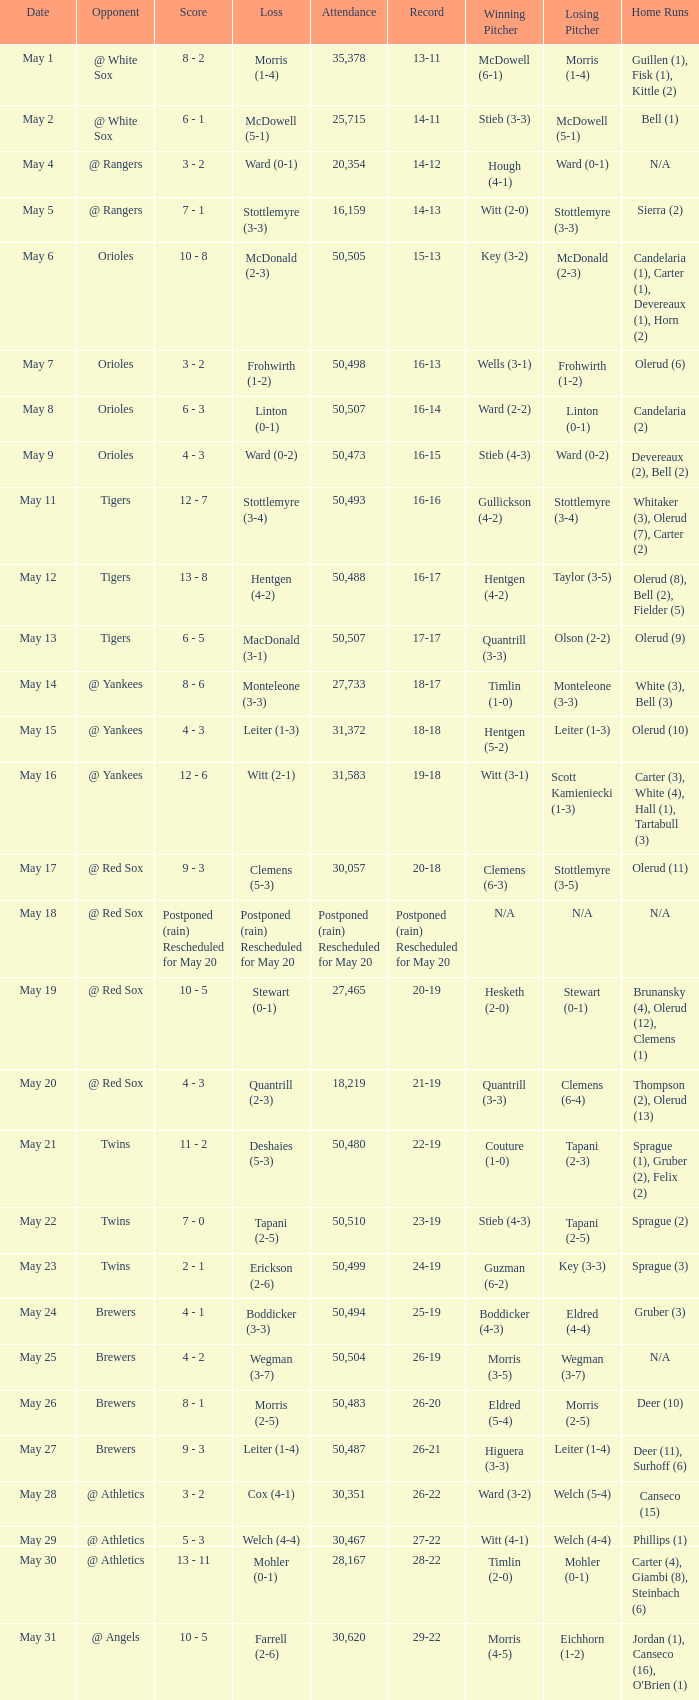Help me parse the entirety of this table. {'header': ['Date', 'Opponent', 'Score', 'Loss', 'Attendance', 'Record', 'Winning Pitcher', 'Losing Pitcher', 'Home Runs'], 'rows': [['May 1', '@ White Sox', '8 - 2', 'Morris (1-4)', '35,378', '13-11', 'McDowell (6-1)', 'Morris (1-4)', 'Guillen (1), Fisk (1), Kittle (2)'], ['May 2', '@ White Sox', '6 - 1', 'McDowell (5-1)', '25,715', '14-11', 'Stieb (3-3)', 'McDowell (5-1)', 'Bell (1)'], ['May 4', '@ Rangers', '3 - 2', 'Ward (0-1)', '20,354', '14-12', 'Hough (4-1)', 'Ward (0-1)', 'N/A'], ['May 5', '@ Rangers', '7 - 1', 'Stottlemyre (3-3)', '16,159', '14-13', 'Witt (2-0)', 'Stottlemyre (3-3)', 'Sierra (2)'], ['May 6', 'Orioles', '10 - 8', 'McDonald (2-3)', '50,505', '15-13', 'Key (3-2)', 'McDonald (2-3)', 'Candelaria (1), Carter (1), Devereaux (1), Horn (2)'], ['May 7', 'Orioles', '3 - 2', 'Frohwirth (1-2)', '50,498', '16-13', 'Wells (3-1)', 'Frohwirth (1-2)', 'Olerud (6)'], ['May 8', 'Orioles', '6 - 3', 'Linton (0-1)', '50,507', '16-14', 'Ward (2-2)', 'Linton (0-1)', 'Candelaria (2)'], ['May 9', 'Orioles', '4 - 3', 'Ward (0-2)', '50,473', '16-15', 'Stieb (4-3)', 'Ward (0-2)', 'Devereaux (2), Bell (2)'], ['May 11', 'Tigers', '12 - 7', 'Stottlemyre (3-4)', '50,493', '16-16', 'Gullickson (4-2)', 'Stottlemyre (3-4)', 'Whitaker (3), Olerud (7), Carter (2)'], ['May 12', 'Tigers', '13 - 8', 'Hentgen (4-2)', '50,488', '16-17', 'Hentgen (4-2)', 'Taylor (3-5)', 'Olerud (8), Bell (2), Fielder (5)'], ['May 13', 'Tigers', '6 - 5', 'MacDonald (3-1)', '50,507', '17-17', 'Quantrill (3-3)', 'Olson (2-2)', 'Olerud (9)'], ['May 14', '@ Yankees', '8 - 6', 'Monteleone (3-3)', '27,733', '18-17', 'Timlin (1-0)', 'Monteleone (3-3)', 'White (3), Bell (3)'], ['May 15', '@ Yankees', '4 - 3', 'Leiter (1-3)', '31,372', '18-18', 'Hentgen (5-2)', 'Leiter (1-3)', 'Olerud (10)'], ['May 16', '@ Yankees', '12 - 6', 'Witt (2-1)', '31,583', '19-18', 'Witt (3-1)', 'Scott Kamieniecki (1-3)', 'Carter (3), White (4), Hall (1), Tartabull (3)'], ['May 17', '@ Red Sox', '9 - 3', 'Clemens (5-3)', '30,057', '20-18', 'Clemens (6-3)', 'Stottlemyre (3-5)', 'Olerud (11)'], ['May 18', '@ Red Sox', 'Postponed (rain) Rescheduled for May 20', 'Postponed (rain) Rescheduled for May 20', 'Postponed (rain) Rescheduled for May 20', 'Postponed (rain) Rescheduled for May 20', 'N/A', 'N/A', 'N/A'], ['May 19', '@ Red Sox', '10 - 5', 'Stewart (0-1)', '27,465', '20-19', 'Hesketh (2-0)', 'Stewart (0-1)', 'Brunansky (4), Olerud (12), Clemens (1)'], ['May 20', '@ Red Sox', '4 - 3', 'Quantrill (2-3)', '18,219', '21-19', 'Quantrill (3-3)', 'Clemens (6-4)', 'Thompson (2), Olerud (13)'], ['May 21', 'Twins', '11 - 2', 'Deshaies (5-3)', '50,480', '22-19', 'Couture (1-0)', 'Tapani (2-3)', 'Sprague (1), Gruber (2), Felix (2)'], ['May 22', 'Twins', '7 - 0', 'Tapani (2-5)', '50,510', '23-19', 'Stieb (4-3)', 'Tapani (2-5)', 'Sprague (2)'], ['May 23', 'Twins', '2 - 1', 'Erickson (2-6)', '50,499', '24-19', 'Guzman (6-2)', 'Key (3-3)', 'Sprague (3)'], ['May 24', 'Brewers', '4 - 1', 'Boddicker (3-3)', '50,494', '25-19', 'Boddicker (4-3)', 'Eldred (4-4)', 'Gruber (3)'], ['May 25', 'Brewers', '4 - 2', 'Wegman (3-7)', '50,504', '26-19', 'Morris (3-5)', 'Wegman (3-7)', 'N/A'], ['May 26', 'Brewers', '8 - 1', 'Morris (2-5)', '50,483', '26-20', 'Eldred (5-4)', 'Morris (2-5)', 'Deer (10)'], ['May 27', 'Brewers', '9 - 3', 'Leiter (1-4)', '50,487', '26-21', 'Higuera (3-3)', 'Leiter (1-4)', 'Deer (11), Surhoff (6)'], ['May 28', '@ Athletics', '3 - 2', 'Cox (4-1)', '30,351', '26-22', 'Ward (3-2)', 'Welch (5-4)', 'Canseco (15)'], ['May 29', '@ Athletics', '5 - 3', 'Welch (4-4)', '30,467', '27-22', 'Witt (4-1)', 'Welch (4-4)', 'Phillips (1)'], ['May 30', '@ Athletics', '13 - 11', 'Mohler (0-1)', '28,167', '28-22', 'Timlin (2-0)', 'Mohler (0-1)', 'Carter (4), Giambi (8), Steinbach (6)'], ['May 31', '@ Angels', '10 - 5', 'Farrell (2-6)', '30,620', '29-22', 'Morris (4-5)', 'Eichhorn (1-2)', "Jordan (1), Canseco (16), O'Brien (1)"]]} On May 29 which team had the loss? Welch (4-4). 